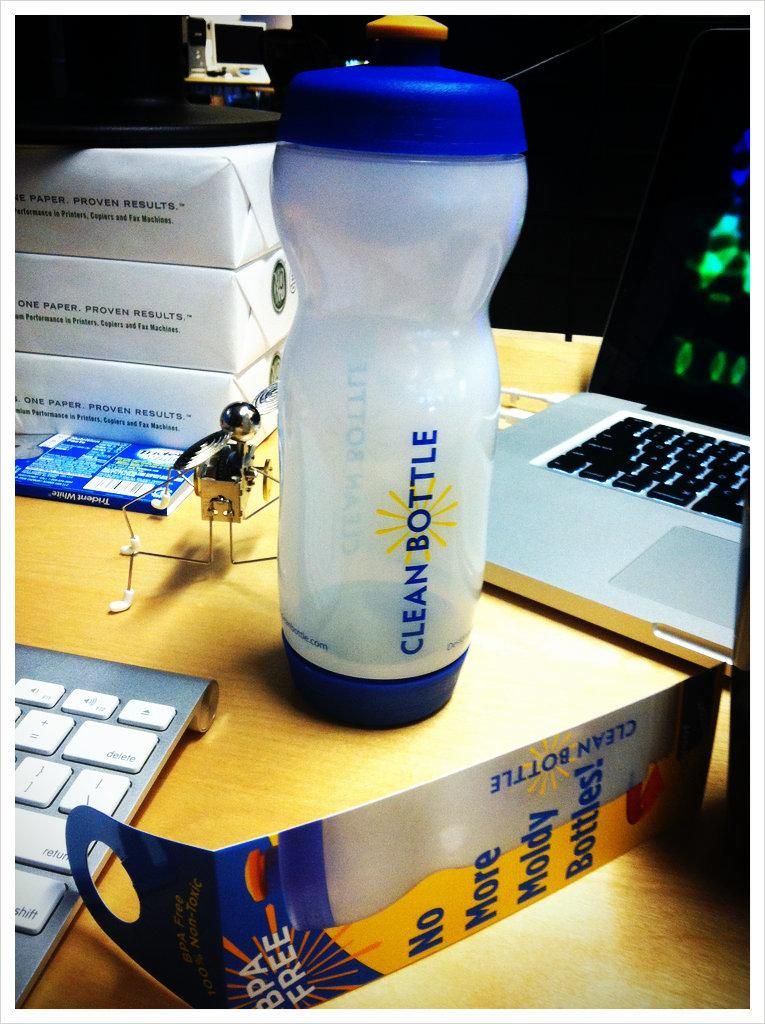<image>
Summarize the visual content of the image. A water bottle that says clean bottle on the side in blue letters. 